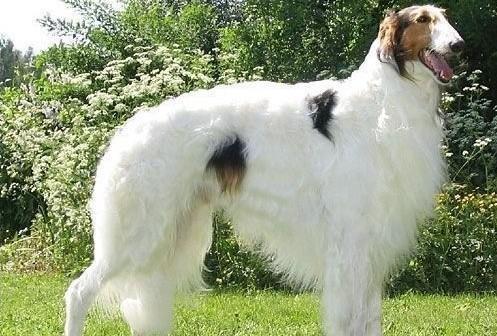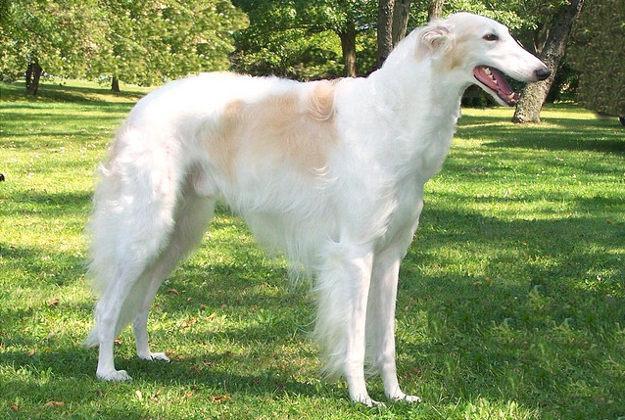The first image is the image on the left, the second image is the image on the right. Assess this claim about the two images: "One dog is standing on all fours, and at least one dog has its head raised distinctly upward.". Correct or not? Answer yes or no. No. The first image is the image on the left, the second image is the image on the right. For the images shown, is this caption "There are two dogs in the image pair, both facing right." true? Answer yes or no. Yes. 